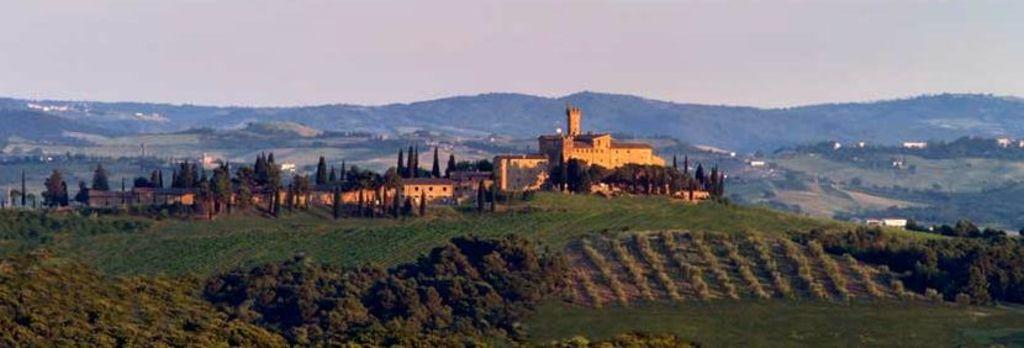What type of scenery is depicted in the image? The image contains a beautiful scenery. What is the dominant vegetation in the image? There is a lot of grass in the image. Are there any trees present in the image? Yes, there are trees in the image. What structure can be seen among the trees? There is a fort in between the trees. What is visible behind the fort? There are mountains behind the fort. What type of twig can be seen in the reaction of the cork in the image? There is no twig, reaction, or cork present in the image. 